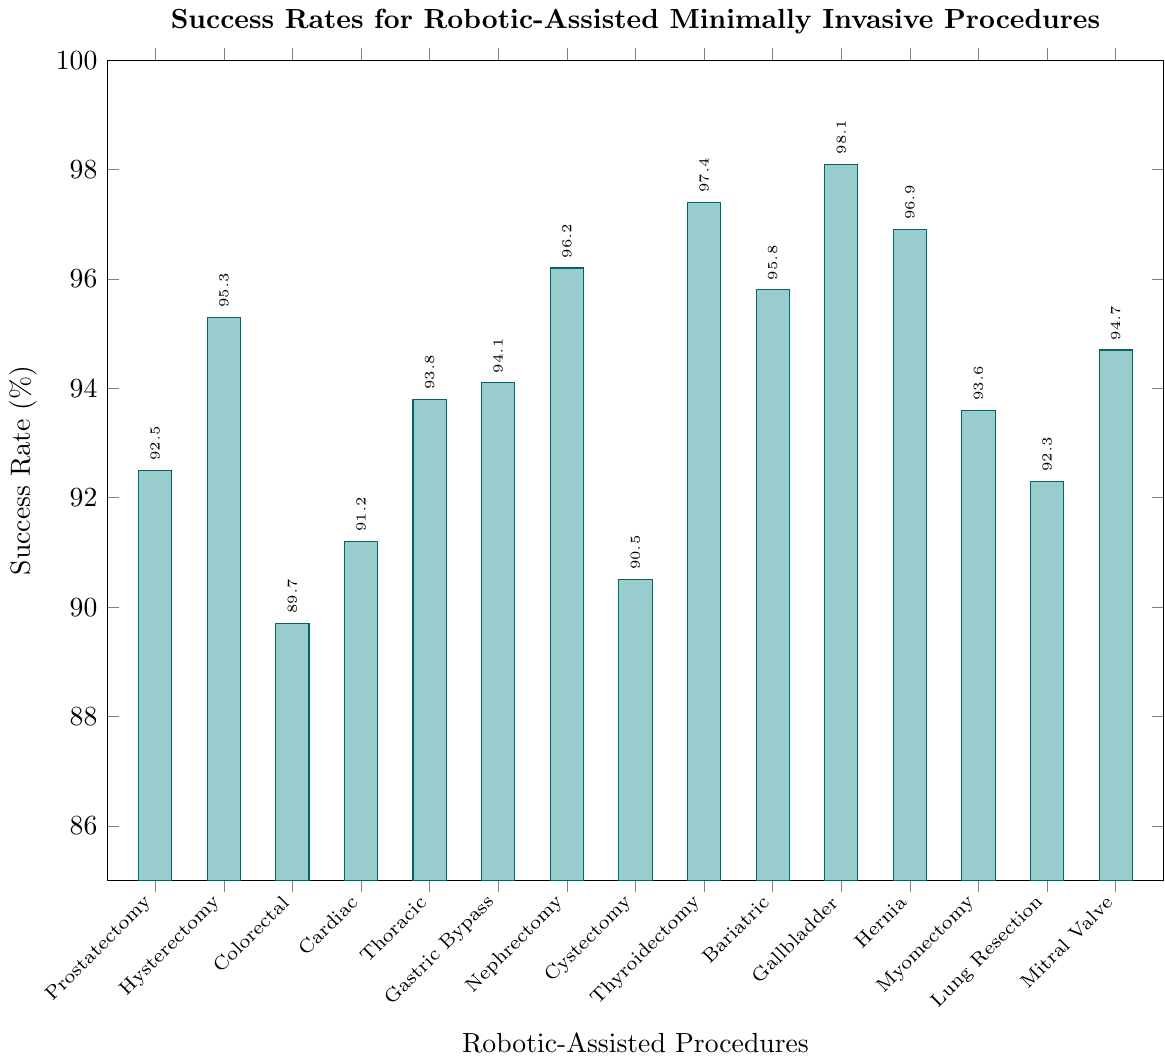What is the success rate of the robotic-assisted procedure with the highest success rate? The procedure with the highest bar represents the procedure with the highest success rate, which is Gallbladder Removal. Its success rate is shown at the top of the bar.
Answer: 98.1% Which robotic-assisted procedure has a lower success rate: Prostatectomy or Cardiac Surgery? Comparing the heights of the bars for Prostatectomy (92.5%) and Cardiac Surgery (91.2%), we see that the Cardiac Surgery bar is shorter, indicating a lower success rate.
Answer: Cardiac Surgery How much greater is the success rate for Gallbladder Removal compared to Colorectal Surgery? The success rate for Gallbladder Removal is 98.1% and for Colorectal Surgery it is 89.7%. Subtract the Colorectal Surgery rate from the Gallbladder Removal rate: 98.1 - 89.7 = 8.4%.
Answer: 8.4% What is the average success rate of all the robotic-assisted procedures? Add up all the success rates and divide by the number of procedures: (92.5 + 95.3 + 89.7 + 91.2 + 93.8 + 94.1 + 96.2 + 90.5 + 97.4 + 95.8 + 98.1 + 96.9 + 93.6 + 92.3 + 94.7) / 15 = 94.3%.
Answer: 94.3% Which robotic-assisted procedure has the closest success rate to the average success rate of all procedures? The average success rate is 94.3%. Identify the procedure with a success rate closest to this value by comparison:
- Gastric Bypass (94.1%) is very close compared to other values around the average.
Answer: Gastric Bypass What is the difference in success rates between the procedures with the highest and lowest success rates? The procedure with the highest success rate is Gallbladder Removal (98.1%), and the procedure with the lowest success rate is Colorectal Surgery (89.7%). Subtract the lowest success rate from the highest: 98.1 - 89.7 = 8.4%.
Answer: 8.4% 